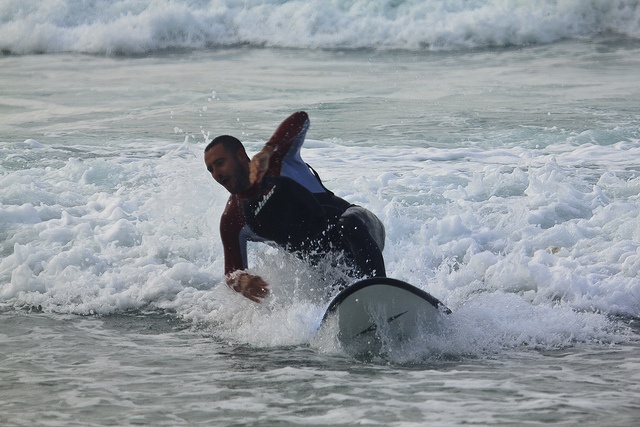Describe the objects in this image and their specific colors. I can see people in darkgray, black, and gray tones and surfboard in darkgray, gray, and black tones in this image. 